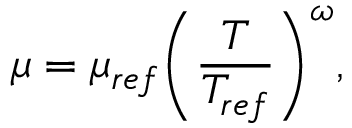Convert formula to latex. <formula><loc_0><loc_0><loc_500><loc_500>\mu = { { \mu } _ { r e f } } { { \left ( \frac { T } { { { T } _ { r e f } } } \right ) } ^ { \omega } } ,</formula> 